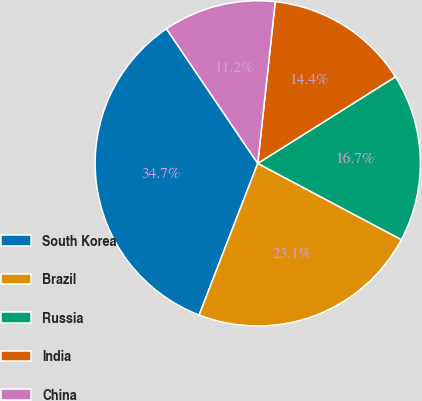Convert chart. <chart><loc_0><loc_0><loc_500><loc_500><pie_chart><fcel>South Korea<fcel>Brazil<fcel>Russia<fcel>India<fcel>China<nl><fcel>34.65%<fcel>23.1%<fcel>16.7%<fcel>14.35%<fcel>11.2%<nl></chart> 